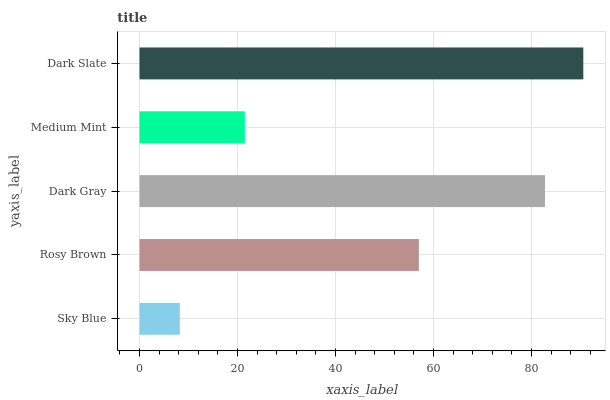Is Sky Blue the minimum?
Answer yes or no. Yes. Is Dark Slate the maximum?
Answer yes or no. Yes. Is Rosy Brown the minimum?
Answer yes or no. No. Is Rosy Brown the maximum?
Answer yes or no. No. Is Rosy Brown greater than Sky Blue?
Answer yes or no. Yes. Is Sky Blue less than Rosy Brown?
Answer yes or no. Yes. Is Sky Blue greater than Rosy Brown?
Answer yes or no. No. Is Rosy Brown less than Sky Blue?
Answer yes or no. No. Is Rosy Brown the high median?
Answer yes or no. Yes. Is Rosy Brown the low median?
Answer yes or no. Yes. Is Dark Slate the high median?
Answer yes or no. No. Is Dark Gray the low median?
Answer yes or no. No. 